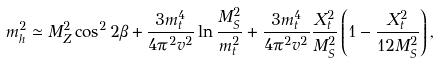Convert formula to latex. <formula><loc_0><loc_0><loc_500><loc_500>m ^ { 2 } _ { h } \simeq M ^ { 2 } _ { Z } \cos ^ { 2 } 2 \beta + \frac { 3 m ^ { 4 } _ { t } } { 4 \pi ^ { 2 } v ^ { 2 } } \ln \frac { M ^ { 2 } _ { S } } { m ^ { 2 } _ { t } } + \frac { 3 m ^ { 4 } _ { t } } { 4 \pi ^ { 2 } v ^ { 2 } } \frac { X ^ { 2 } _ { t } } { M _ { S } ^ { 2 } } \left ( 1 - \frac { X ^ { 2 } _ { t } } { 1 2 M ^ { 2 } _ { S } } \right ) ,</formula> 